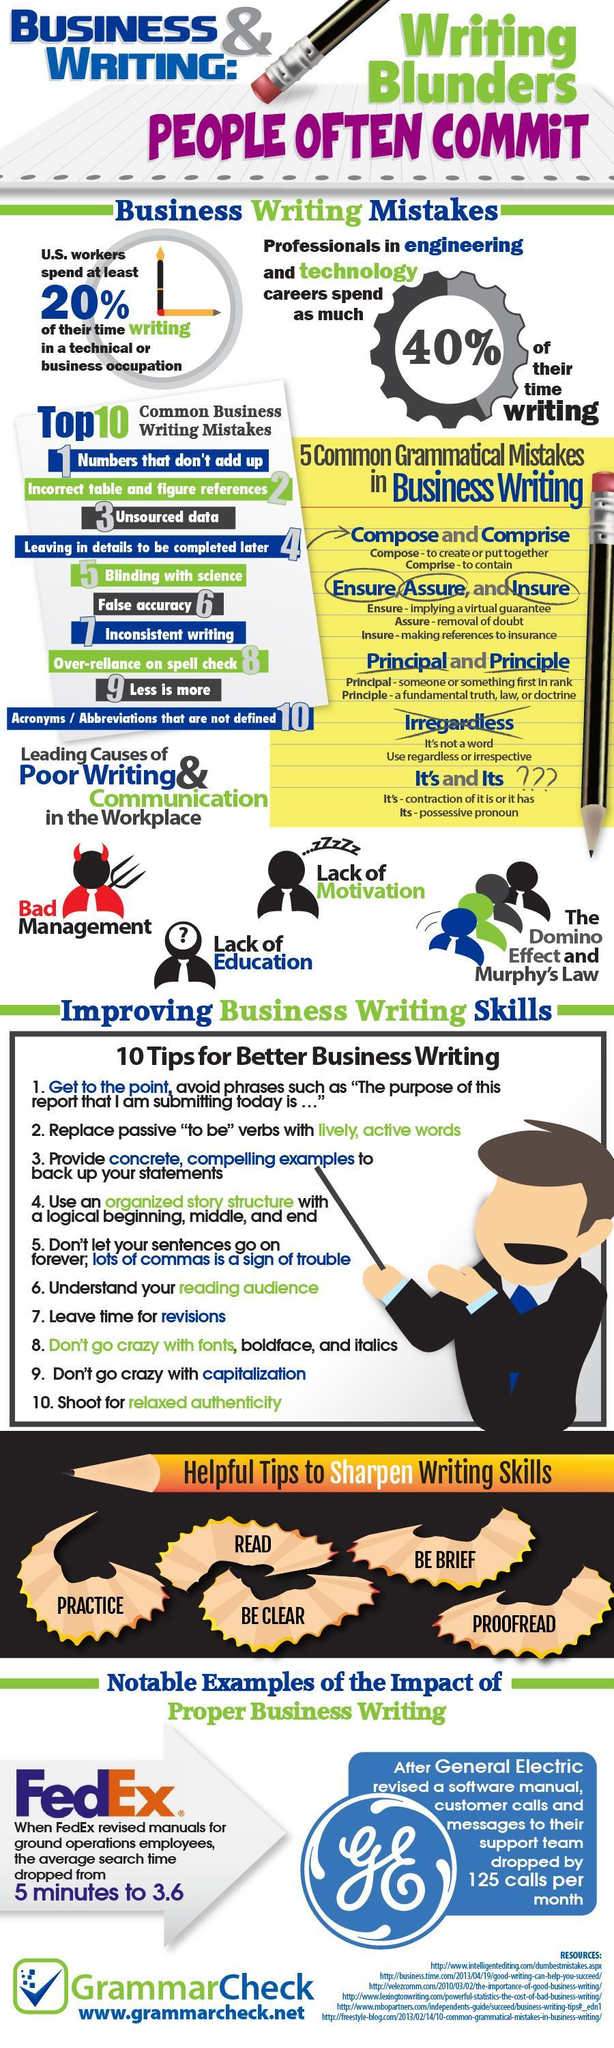What is the top no.3 common business writing mistakes that occur?
Answer the question with a short phrase. Unsourced data What is the decrease in the average search time when the fedex revised manuals for ground operations employees? 5 minutes to 3.6 What percentage of time do the professionals in engineering & technology careers spend for writing? 40% What is the least common business writing mistake that occur? Acronyms / Abbreviations that are not defined 